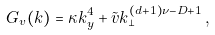<formula> <loc_0><loc_0><loc_500><loc_500>G _ { v } ( { k } ) = \kappa k _ { y } ^ { 4 } + \tilde { v } k _ { \perp } ^ { ( d + 1 ) \nu - D + 1 } \, ,</formula> 